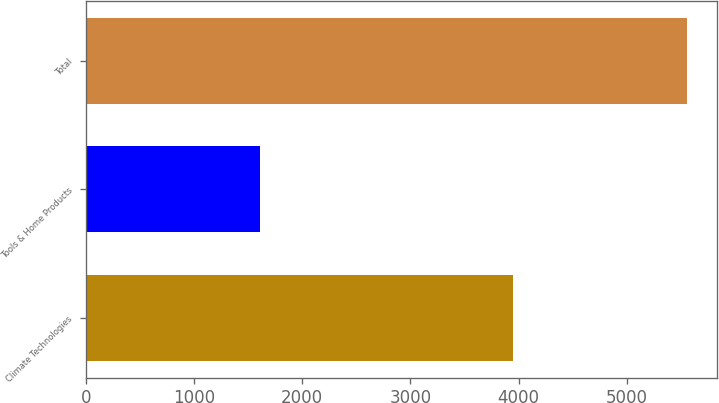<chart> <loc_0><loc_0><loc_500><loc_500><bar_chart><fcel>Climate Technologies<fcel>Tools & Home Products<fcel>Total<nl><fcel>3944<fcel>1611<fcel>5555<nl></chart> 